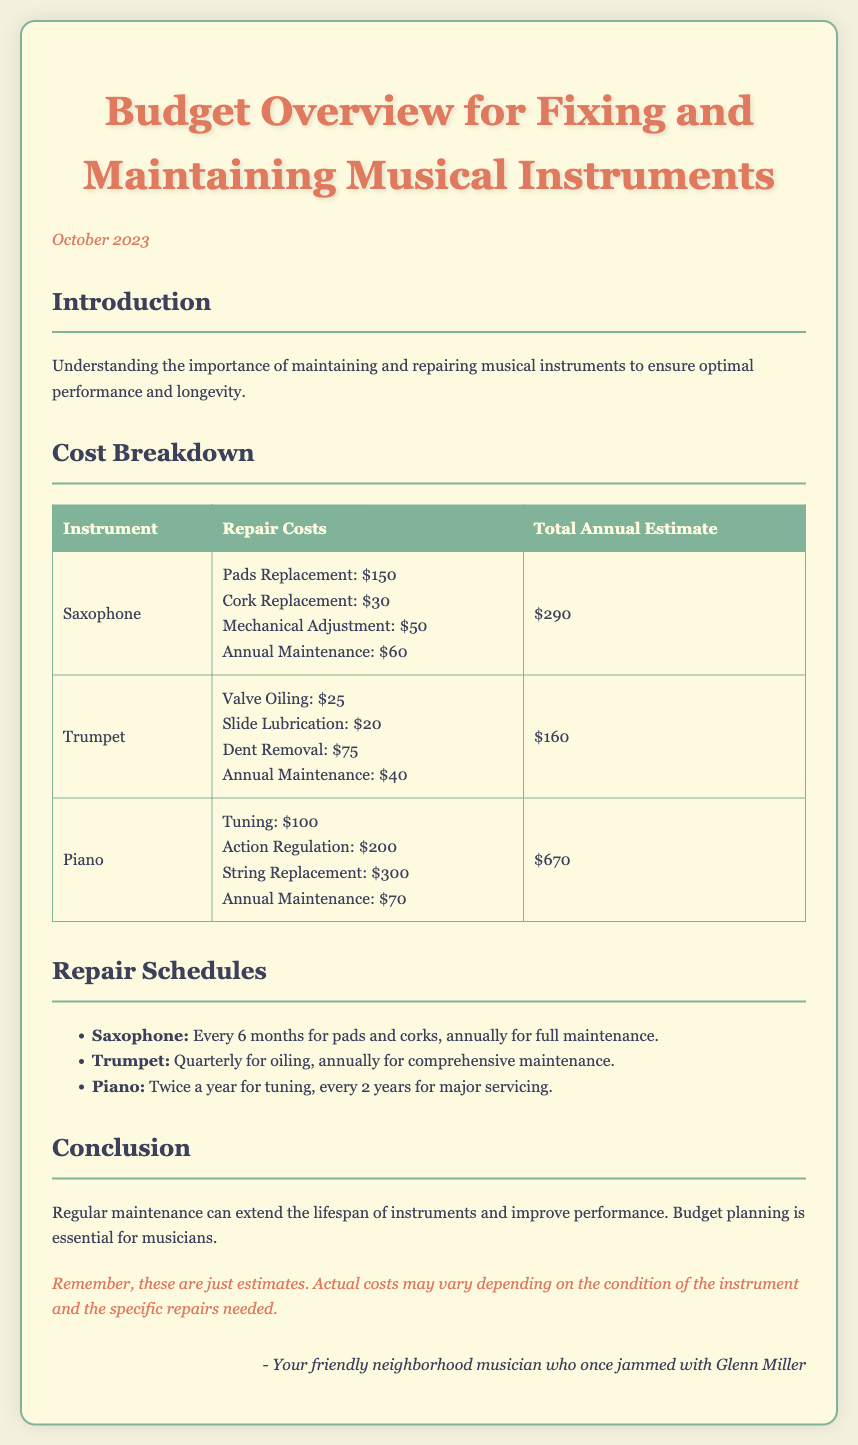What is the total annual estimate for the saxophone? The total annual estimate for the saxophone is listed in the document as $290.
Answer: $290 What is included in the trumpet repair costs? The repair costs for the trumpet include Valve Oiling, Slide Lubrication, Dent Removal, and Annual Maintenance.
Answer: Valve Oiling, Slide Lubrication, Dent Removal, Annual Maintenance How often should the piano be tuned? The document specifies that the piano should be tuned twice a year.
Answer: Twice a year What is the repair cost for string replacement on the piano? The repair cost for string replacement on the piano is noted as $300.
Answer: $300 What is the annual maintenance cost for the saxophone? The annual maintenance cost for the saxophone is mentioned as $60.
Answer: $60 How many times a year is trumpet oiling scheduled? The document states that trumpet oiling is scheduled quarterly, which is four times a year.
Answer: Quarterly What is the total estimated cost for maintaining a piano annually? The total estimated cost for maintaining a piano annually sums up to $670, as stated in the document.
Answer: $670 What maintenance is recommended for the saxophone every six months? The document recommends pads and cork replacement for the saxophone every six months.
Answer: Pads and cork replacement What is the document's purpose? The purpose is to provide an overview of the budget for fixing and maintaining musical instruments, emphasizing the importance of maintenance.
Answer: Budget overview for fixing and maintaining musical instruments 